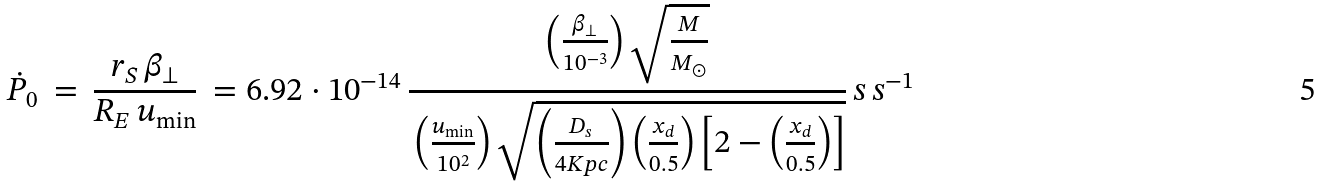<formula> <loc_0><loc_0><loc_500><loc_500>\dot { P } _ { 0 } \, = \, \frac { r _ { S } \, \beta _ { \perp } } { R _ { E } \, u _ { \min } } \, = 6 . 9 2 \cdot 1 0 ^ { - 1 4 } \, \frac { \left ( \frac { \beta _ { \perp } } { 1 0 ^ { - 3 } } \right ) \sqrt { \frac { M } { M _ { \odot } } } } { \, \left ( \frac { u _ { \min } } { 1 0 ^ { 2 } } \right ) \sqrt { \left ( \frac { D _ { s } } { 4 K p c } \right ) \left ( \frac { x _ { d } } { 0 . 5 } \right ) \left [ 2 - \left ( \frac { x _ { d } } { 0 . 5 } \right ) \right ] } } \, s \, s ^ { - 1 }</formula> 